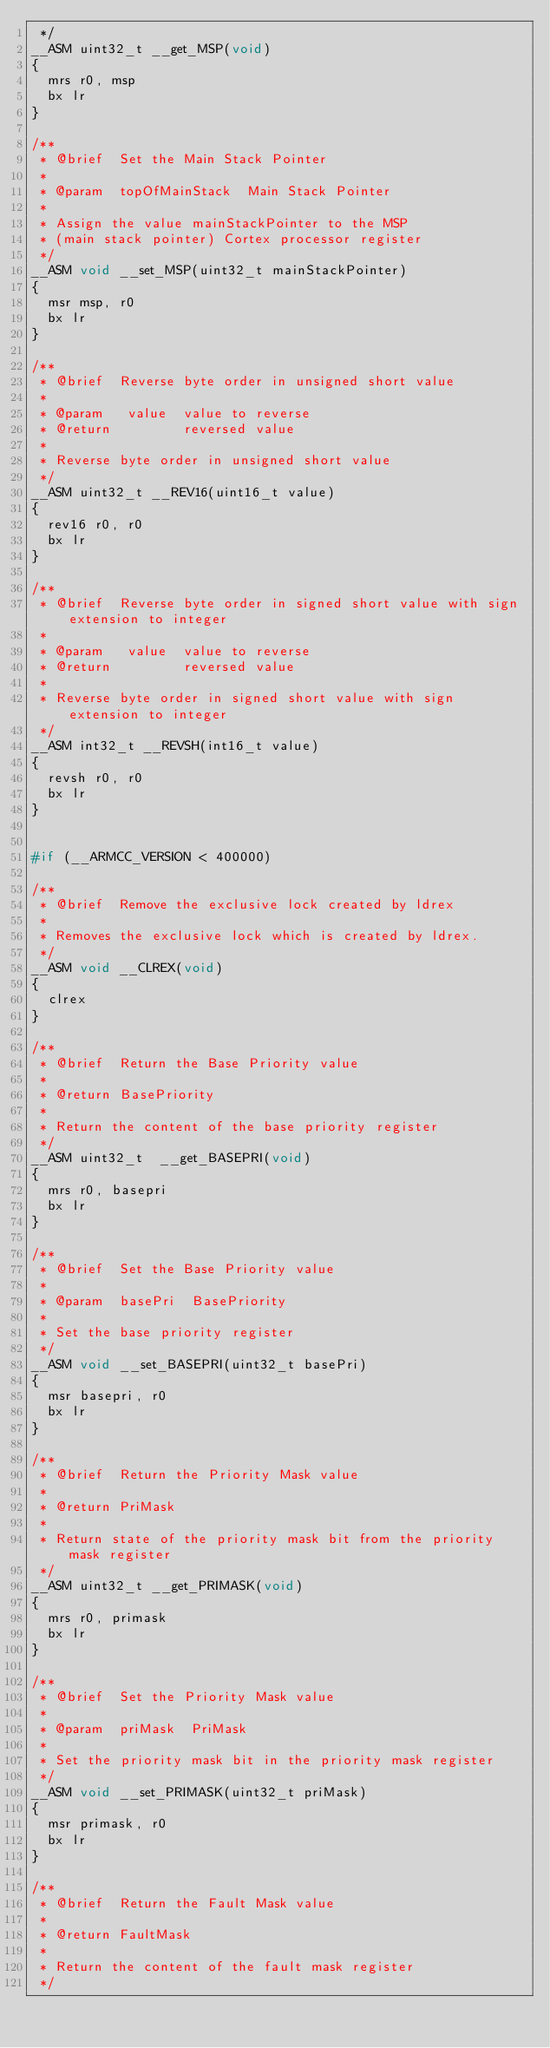<code> <loc_0><loc_0><loc_500><loc_500><_C_> */
__ASM uint32_t __get_MSP(void)
{
  mrs r0, msp
  bx lr
}

/**
 * @brief  Set the Main Stack Pointer
 *
 * @param  topOfMainStack  Main Stack Pointer
 *
 * Assign the value mainStackPointer to the MSP 
 * (main stack pointer) Cortex processor register
 */
__ASM void __set_MSP(uint32_t mainStackPointer)
{
  msr msp, r0
  bx lr
}

/**
 * @brief  Reverse byte order in unsigned short value
 *
 * @param   value  value to reverse
 * @return         reversed value
 *
 * Reverse byte order in unsigned short value
 */
__ASM uint32_t __REV16(uint16_t value)
{
  rev16 r0, r0
  bx lr
}

/**
 * @brief  Reverse byte order in signed short value with sign extension to integer
 *
 * @param   value  value to reverse
 * @return         reversed value
 *
 * Reverse byte order in signed short value with sign extension to integer
 */
__ASM int32_t __REVSH(int16_t value)
{
  revsh r0, r0
  bx lr
}


#if (__ARMCC_VERSION < 400000)

/**
 * @brief  Remove the exclusive lock created by ldrex
 *
 * Removes the exclusive lock which is created by ldrex.
 */
__ASM void __CLREX(void)
{
  clrex
}

/**
 * @brief  Return the Base Priority value
 *
 * @return BasePriority
 *
 * Return the content of the base priority register
 */
__ASM uint32_t  __get_BASEPRI(void)
{
  mrs r0, basepri
  bx lr
}

/**
 * @brief  Set the Base Priority value
 *
 * @param  basePri  BasePriority
 *
 * Set the base priority register
 */
__ASM void __set_BASEPRI(uint32_t basePri)
{
  msr basepri, r0
  bx lr
}

/**
 * @brief  Return the Priority Mask value
 *
 * @return PriMask
 *
 * Return state of the priority mask bit from the priority mask register
 */
__ASM uint32_t __get_PRIMASK(void)
{
  mrs r0, primask
  bx lr
}

/**
 * @brief  Set the Priority Mask value
 *
 * @param  priMask  PriMask
 *
 * Set the priority mask bit in the priority mask register
 */
__ASM void __set_PRIMASK(uint32_t priMask)
{
  msr primask, r0
  bx lr
}

/**
 * @brief  Return the Fault Mask value
 *
 * @return FaultMask
 *
 * Return the content of the fault mask register
 */</code> 